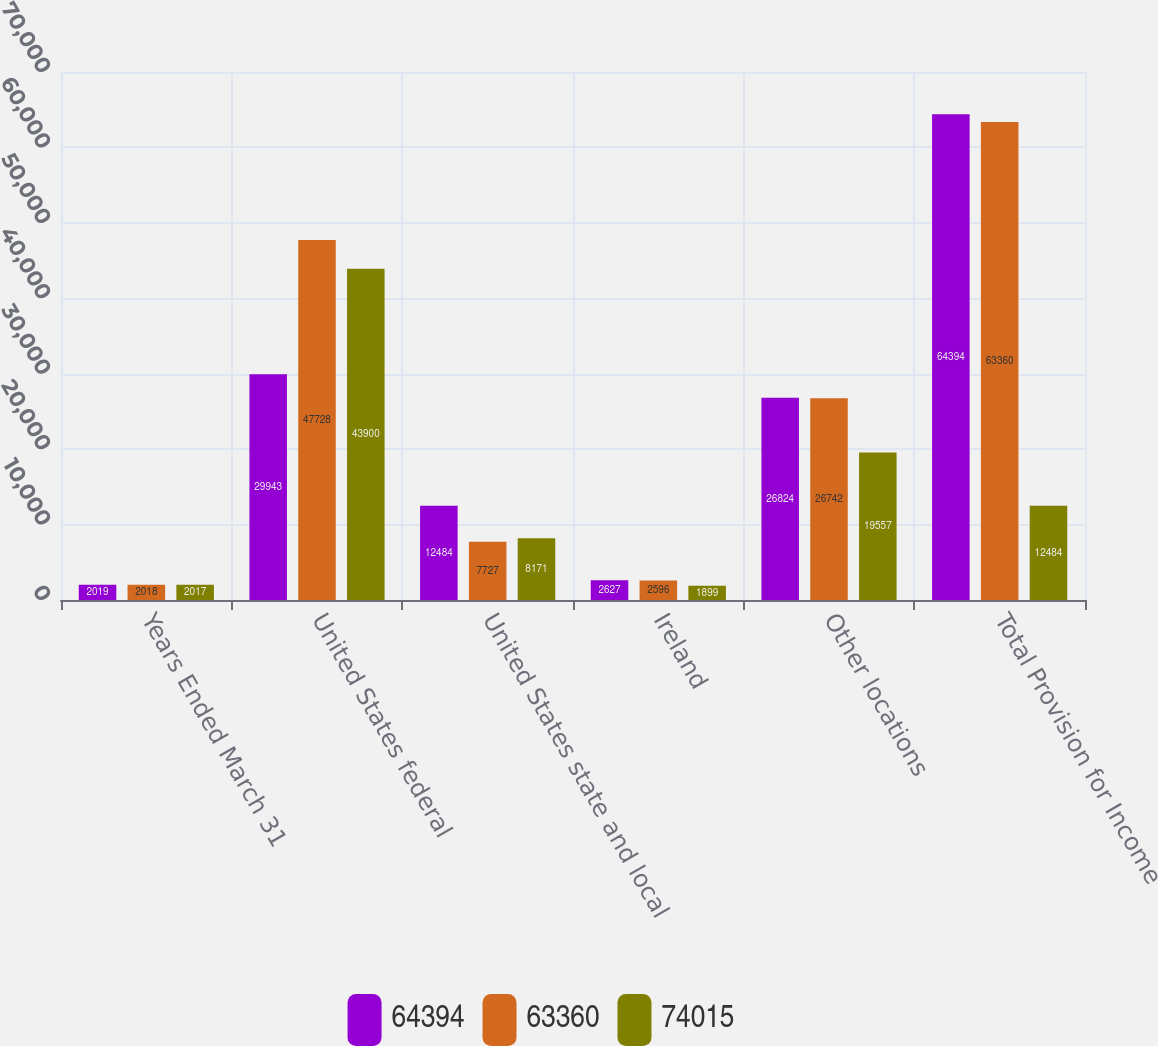<chart> <loc_0><loc_0><loc_500><loc_500><stacked_bar_chart><ecel><fcel>Years Ended March 31<fcel>United States federal<fcel>United States state and local<fcel>Ireland<fcel>Other locations<fcel>Total Provision for Income<nl><fcel>64394<fcel>2019<fcel>29943<fcel>12484<fcel>2627<fcel>26824<fcel>64394<nl><fcel>63360<fcel>2018<fcel>47728<fcel>7727<fcel>2596<fcel>26742<fcel>63360<nl><fcel>74015<fcel>2017<fcel>43900<fcel>8171<fcel>1899<fcel>19557<fcel>12484<nl></chart> 